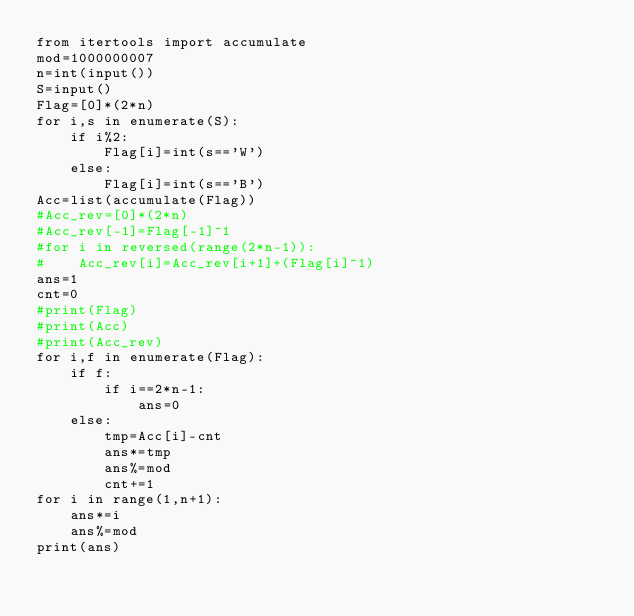Convert code to text. <code><loc_0><loc_0><loc_500><loc_500><_Python_>from itertools import accumulate
mod=1000000007
n=int(input())
S=input()
Flag=[0]*(2*n)
for i,s in enumerate(S):
    if i%2:
        Flag[i]=int(s=='W')
    else:
        Flag[i]=int(s=='B')
Acc=list(accumulate(Flag))
#Acc_rev=[0]*(2*n)
#Acc_rev[-1]=Flag[-1]^1
#for i in reversed(range(2*n-1)):
#    Acc_rev[i]=Acc_rev[i+1]+(Flag[i]^1)
ans=1
cnt=0
#print(Flag)
#print(Acc)
#print(Acc_rev)
for i,f in enumerate(Flag):
    if f:
        if i==2*n-1:
            ans=0
    else:
        tmp=Acc[i]-cnt
        ans*=tmp
        ans%=mod
        cnt+=1
for i in range(1,n+1):
    ans*=i
    ans%=mod
print(ans)</code> 